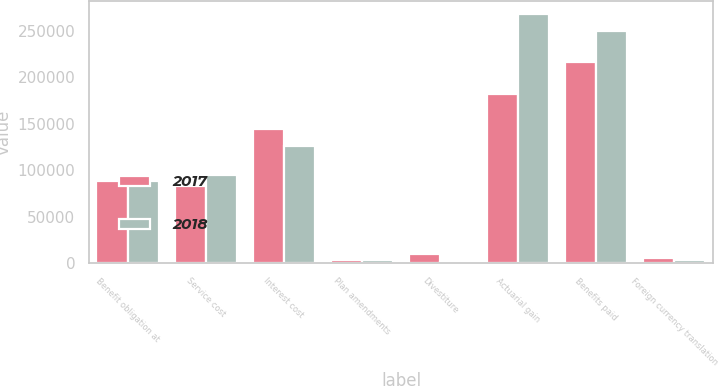<chart> <loc_0><loc_0><loc_500><loc_500><stacked_bar_chart><ecel><fcel>Benefit obligation at<fcel>Service cost<fcel>Interest cost<fcel>Plan amendments<fcel>Divestiture<fcel>Actuarial gain<fcel>Benefits paid<fcel>Foreign currency translation<nl><fcel>2017<fcel>88674.5<fcel>82993<fcel>144339<fcel>2932<fcel>9535<fcel>182588<fcel>216169<fcel>5832<nl><fcel>2018<fcel>88674.5<fcel>94356<fcel>126131<fcel>3265<fcel>851<fcel>268370<fcel>250289<fcel>3323<nl></chart> 